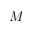<formula> <loc_0><loc_0><loc_500><loc_500>M</formula> 